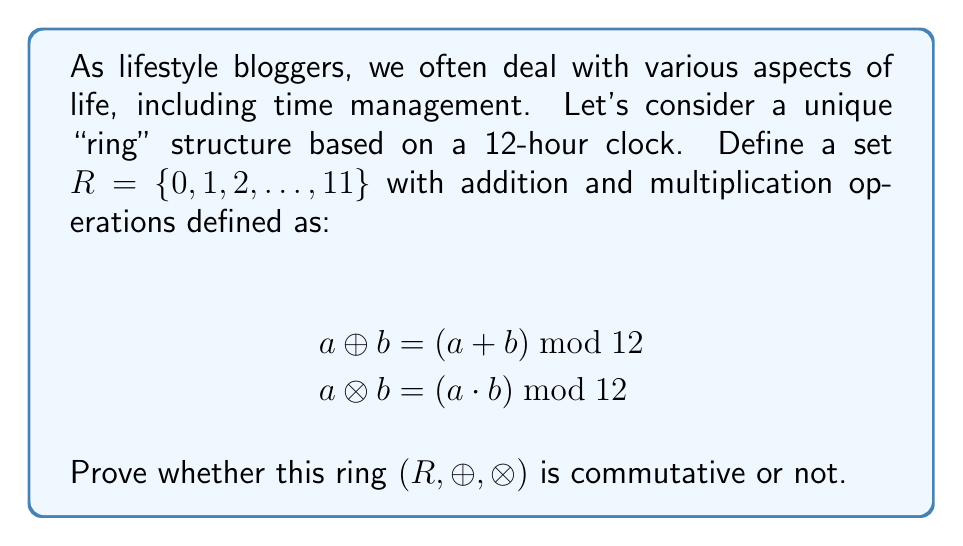What is the answer to this math problem? To prove whether the ring $(R, \oplus, \otimes)$ is commutative or not, we need to check if both addition and multiplication operations are commutative.

1. Commutativity of addition $(\oplus)$:
   For any $a, b \in R$, we need to show that $a \oplus b = b \oplus a$
   
   $a \oplus b = (a + b) \mod 12$
   $b \oplus a = (b + a) \mod 12$
   
   Since regular addition is commutative, $(a + b) = (b + a)$, and the modulo operation doesn't affect this property, we can conclude that $\oplus$ is commutative.

2. Commutativity of multiplication $(\otimes)$:
   For any $a, b \in R$, we need to show that $a \otimes b = b \otimes a$
   
   $a \otimes b = (a \cdot b) \mod 12$
   $b \otimes a = (b \cdot a) \mod 12$
   
   Since regular multiplication is commutative, $(a \cdot b) = (b \cdot a)$, and the modulo operation doesn't affect this property, we can conclude that $\otimes$ is commutative.

Since both addition and multiplication operations are commutative, we can conclude that the ring $(R, \oplus, \otimes)$ is commutative.
Answer: The ring $(R, \oplus, \otimes)$ is commutative. 